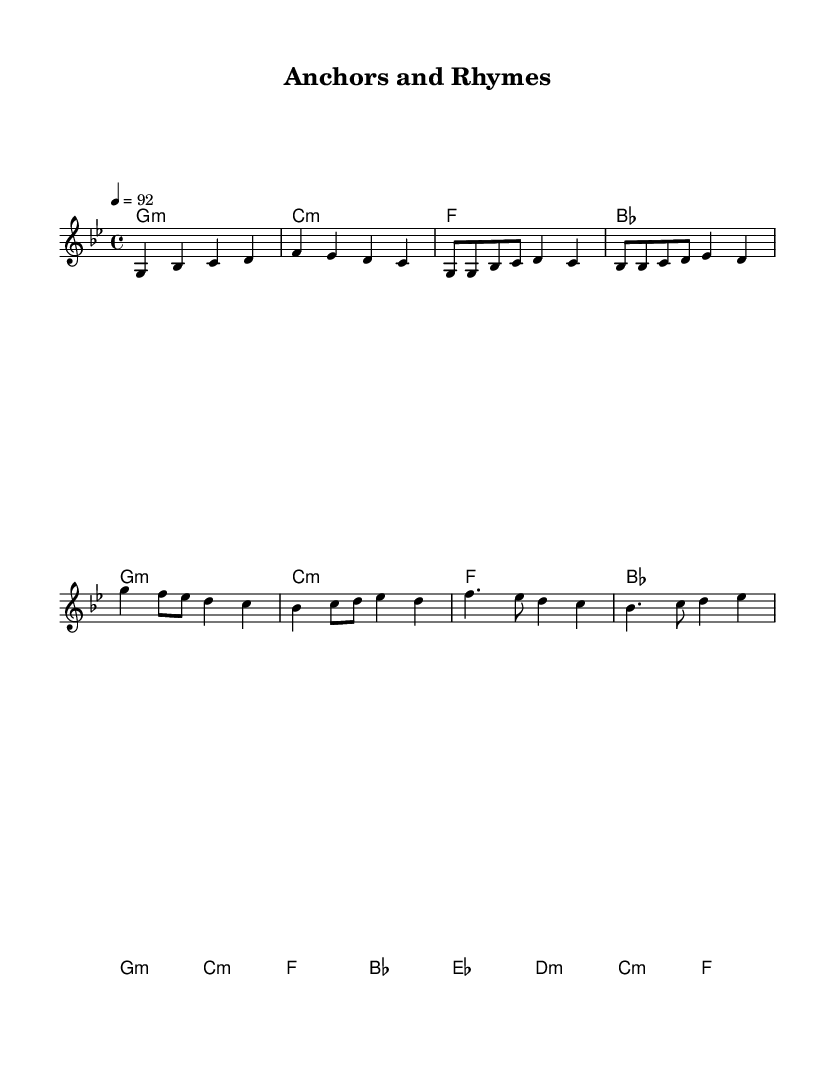What is the key signature of this music? The key signature is G minor, which has two flats (B flat and E flat). This can be identified by looking at the key signature at the beginning of the piece where the flats are indicated.
Answer: G minor What is the time signature of this music? The time signature is 4/4, which means there are four beats in each measure and the quarter note gets one beat. This can be found at the beginning of the score next to the key signature.
Answer: 4/4 What is the tempo marking given in the music? The tempo marking is 92 beats per minute, indicated by the number following the word "tempo". This tells performers how fast or slow to play the piece.
Answer: 92 How many measures are in the chorus section? The chorus section consists of two measures, repeated twice in the score. Counting the measures in the corresponding part of the sheet music reveals this.
Answer: 2 What type of chords are used in the chorus? The chords in the chorus are minor, specifically G minor, C minor, F, and B flat. This can be determined by examining the chord names written above the staff during the chorus section.
Answer: Minor What is the structure of the song in terms of sections? The structure consists of an Intro, Verse, Chorus, and Bridge. This can be understood by looking at the layout of the music and the labels indicating each section.
Answer: Intro, Verse, Chorus, Bridge Which section of the sheet music contains the longest note value? The longest note value appears in the Bridge section, specifically the half note and dotted half note. This is observed by scanning through the note values in the different sections and identifying the longest ones.
Answer: Bridge 